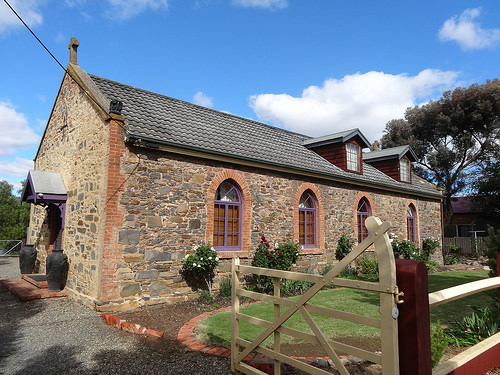<image>
Is there a window above the gate? No. The window is not positioned above the gate. The vertical arrangement shows a different relationship. 